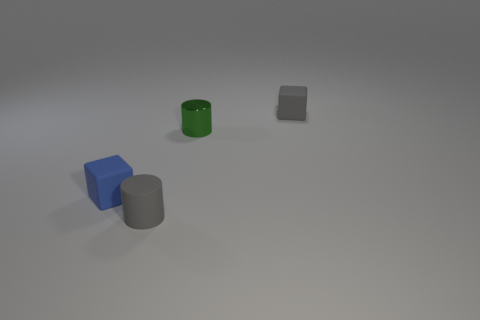There is a cylinder in front of the blue matte object behind the cylinder that is on the left side of the green object; what size is it? The cylinder in front of the blue matte object, which is itself behind another cylinder on the left side of the green object, appears to be small in proportion to the other objects in the image. 